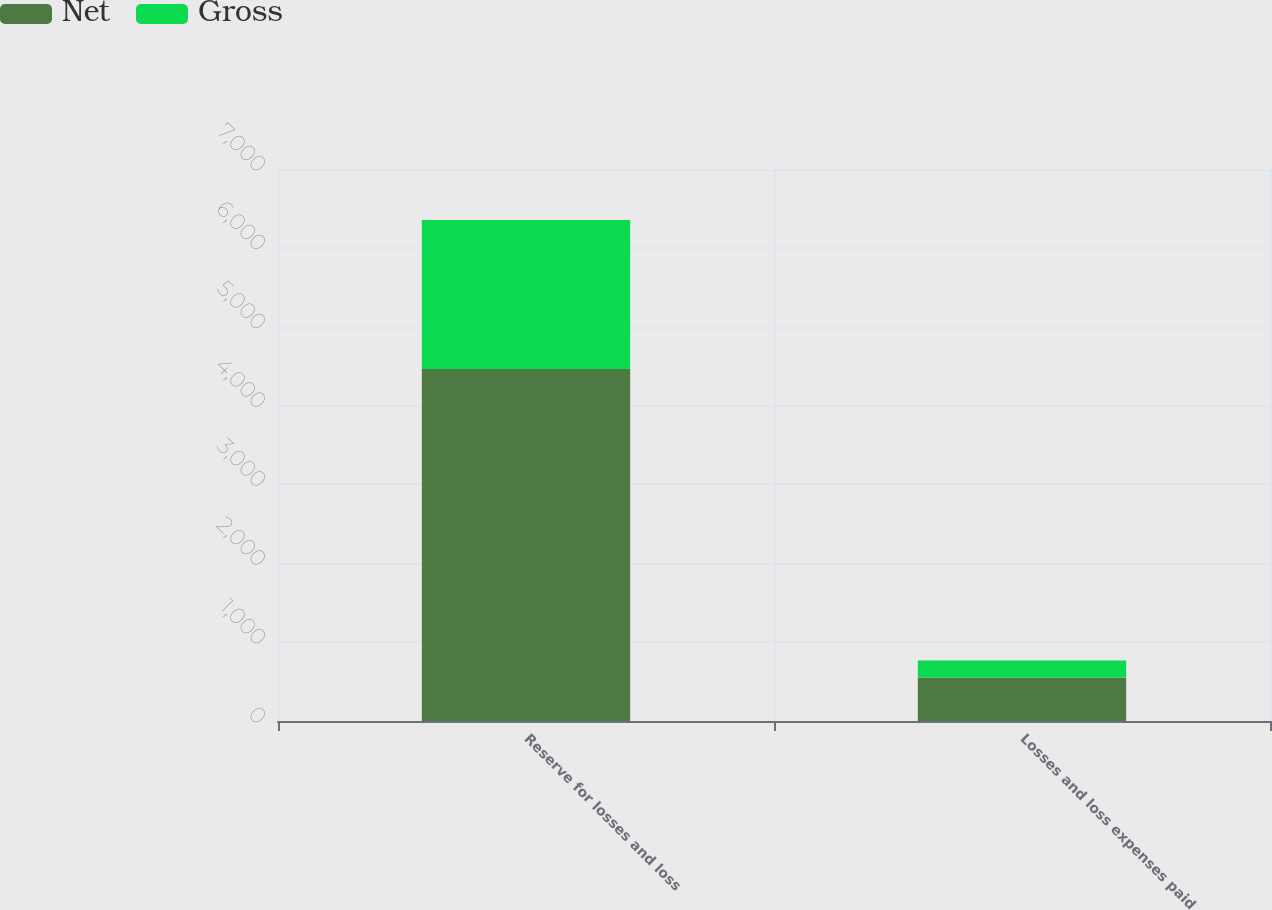<chart> <loc_0><loc_0><loc_500><loc_500><stacked_bar_chart><ecel><fcel>Reserve for losses and loss<fcel>Losses and loss expenses paid<nl><fcel>Net<fcel>4464<fcel>548<nl><fcel>Gross<fcel>1889<fcel>218<nl></chart> 